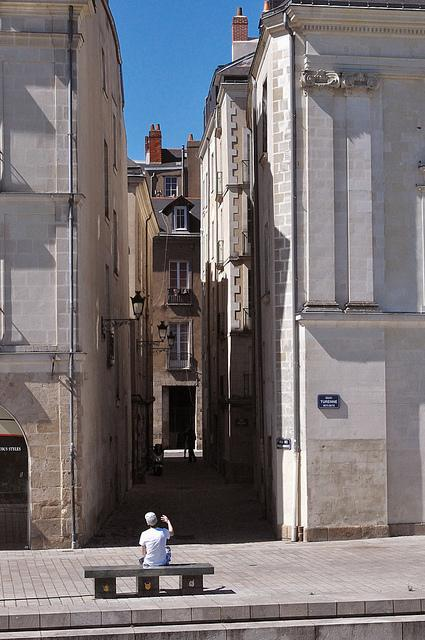Why does the man seated have his arm up? Please explain your reasoning. gesture. The man is seated with his arm up to gesture at the alleyway. 